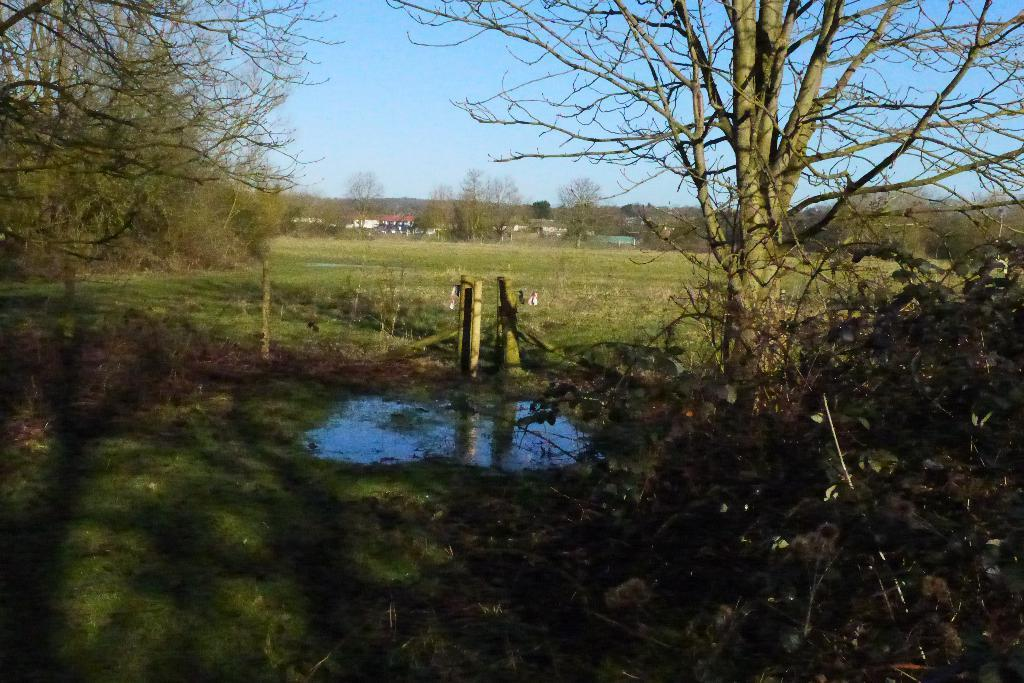What is the primary element in the image? There is water in the image. What type of vegetation can be seen on the path? Some grass is visible on a path. What can be seen in the distance in the image? There are trees and houses in the background of the image. What color is the sky in the image? The sky is blue in color. Can you hear the roof of the house in the image? There is no sound or reference to a roof in the image, so it is not possible to hear it. 